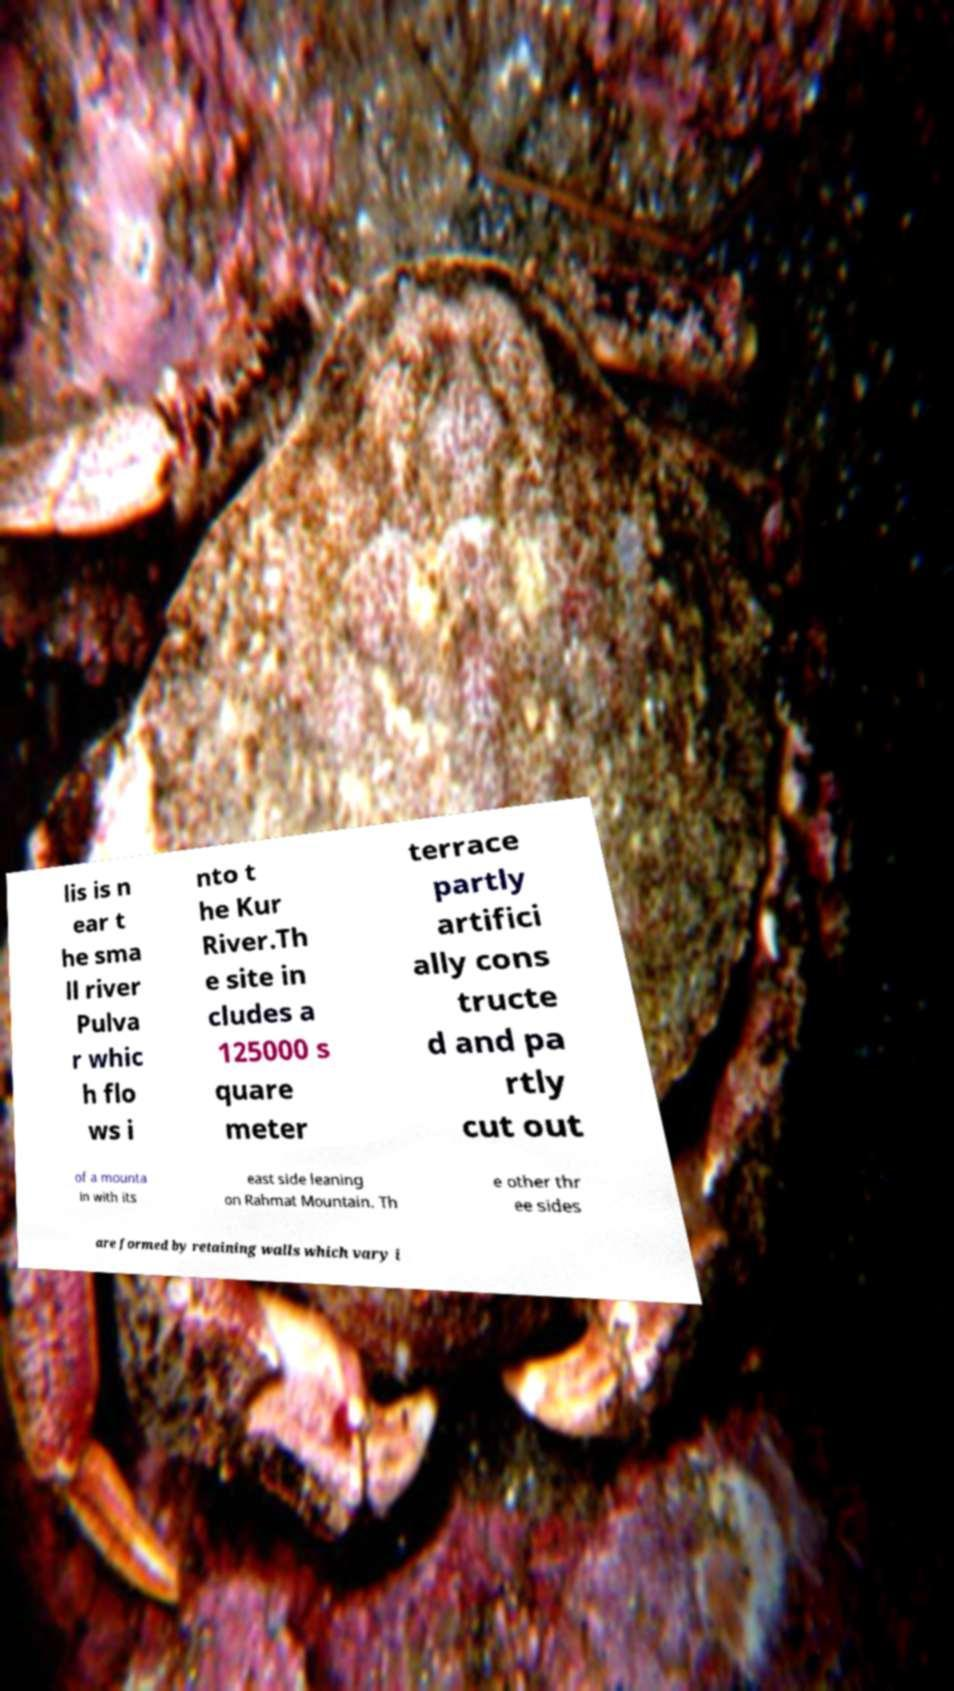Can you accurately transcribe the text from the provided image for me? lis is n ear t he sma ll river Pulva r whic h flo ws i nto t he Kur River.Th e site in cludes a 125000 s quare meter terrace partly artifici ally cons tructe d and pa rtly cut out of a mounta in with its east side leaning on Rahmat Mountain. Th e other thr ee sides are formed by retaining walls which vary i 